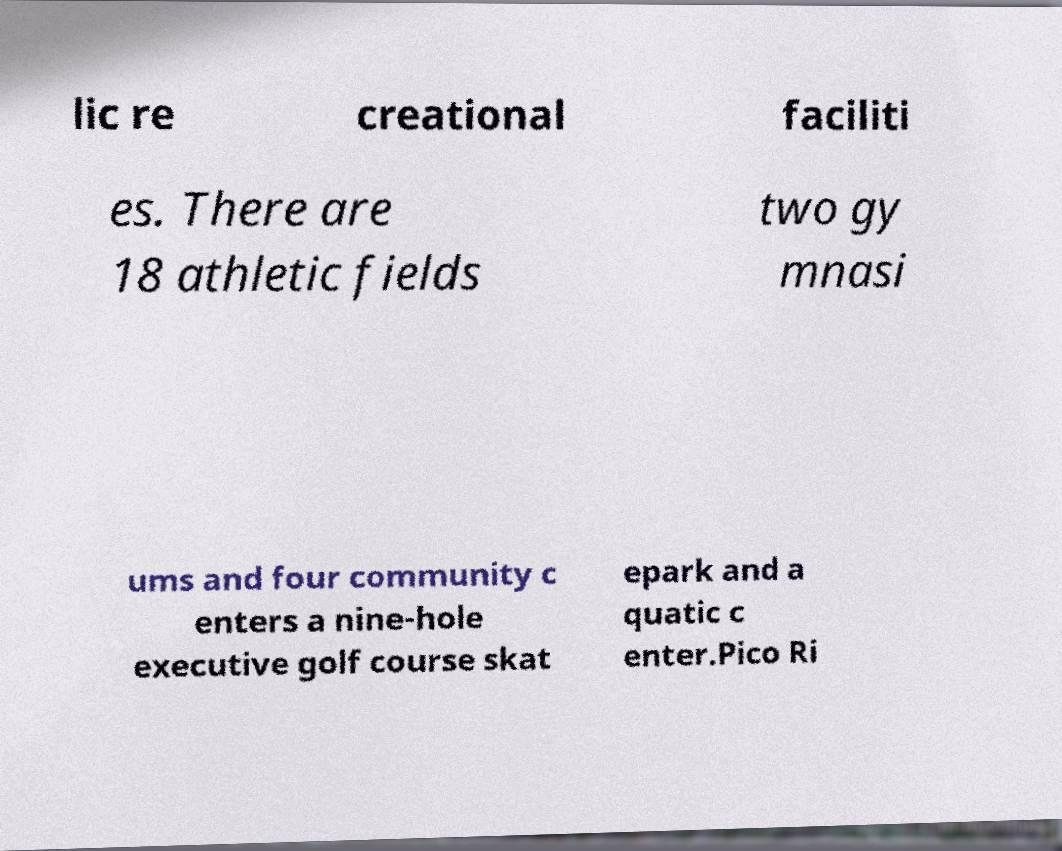Can you accurately transcribe the text from the provided image for me? lic re creational faciliti es. There are 18 athletic fields two gy mnasi ums and four community c enters a nine-hole executive golf course skat epark and a quatic c enter.Pico Ri 